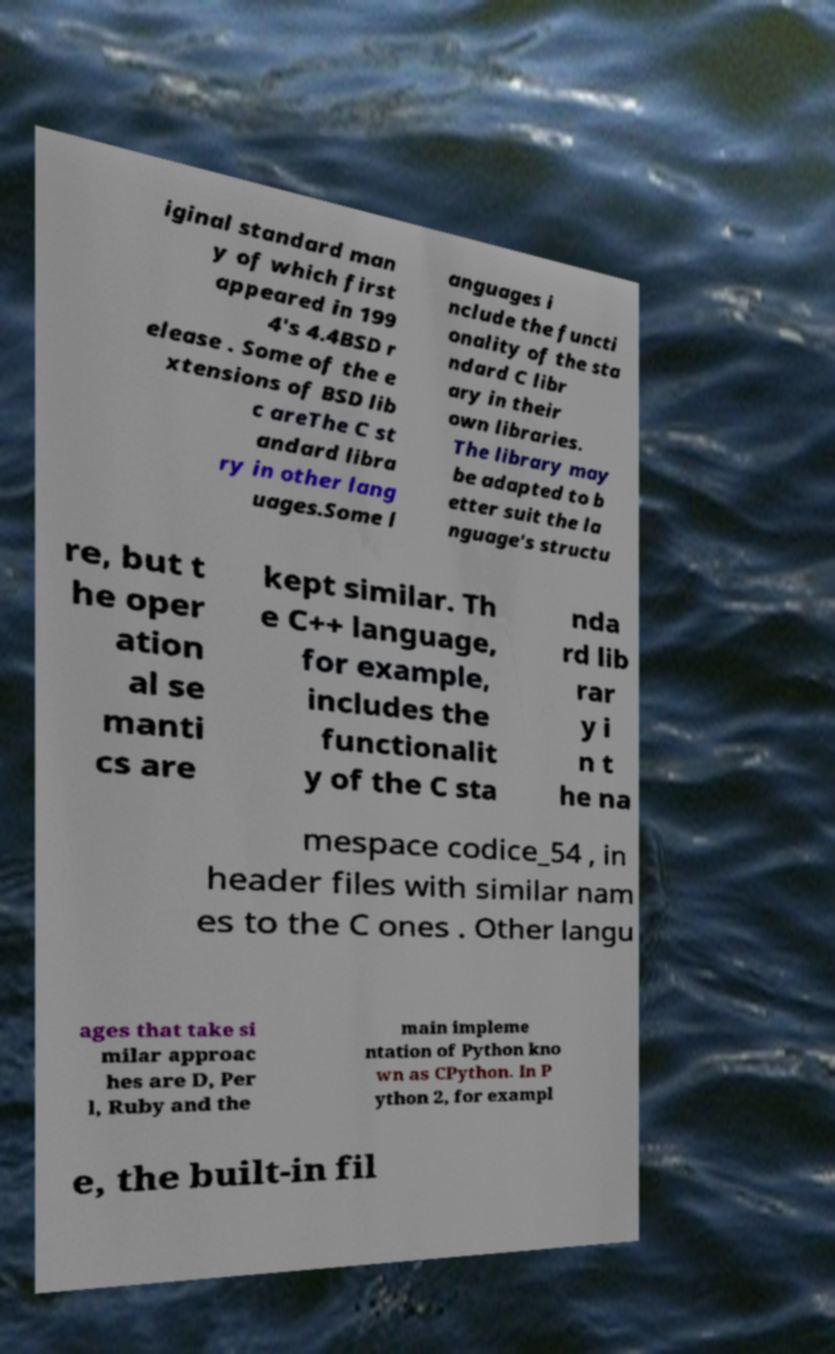For documentation purposes, I need the text within this image transcribed. Could you provide that? iginal standard man y of which first appeared in 199 4's 4.4BSD r elease . Some of the e xtensions of BSD lib c areThe C st andard libra ry in other lang uages.Some l anguages i nclude the functi onality of the sta ndard C libr ary in their own libraries. The library may be adapted to b etter suit the la nguage's structu re, but t he oper ation al se manti cs are kept similar. Th e C++ language, for example, includes the functionalit y of the C sta nda rd lib rar y i n t he na mespace codice_54 , in header files with similar nam es to the C ones . Other langu ages that take si milar approac hes are D, Per l, Ruby and the main impleme ntation of Python kno wn as CPython. In P ython 2, for exampl e, the built-in fil 